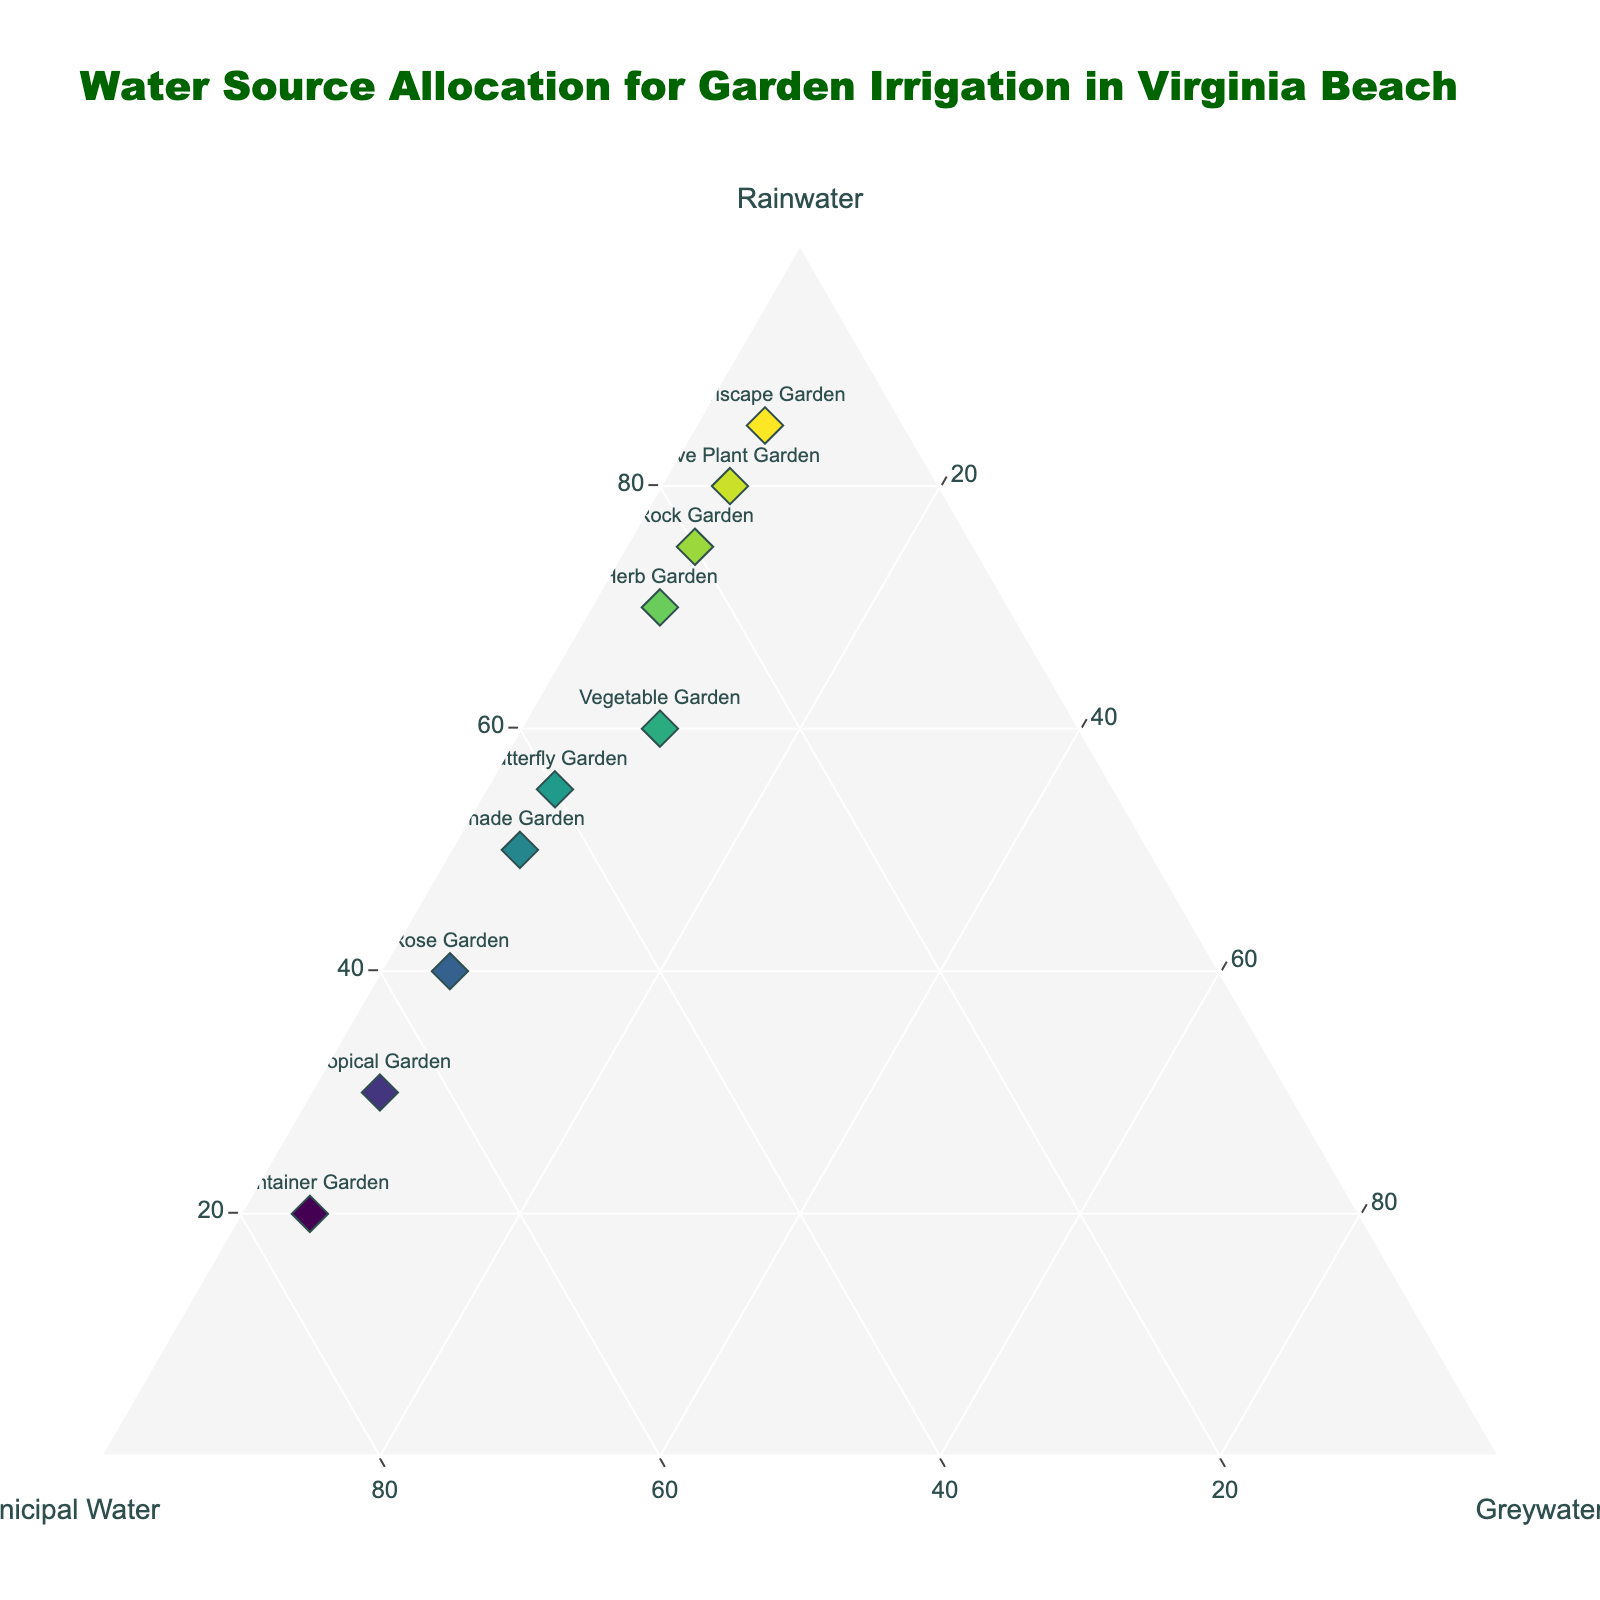What is the title of the ternary plot? The title of the plot is a main visual element and is prominently placed at the top of the figure.
Answer: Water Source Allocation for Garden Irrigation in Virginia Beach Which garden type uses the highest percentage of rainwater? Look for the garden type positioned closest to the Rainwater axis. The label corresponding to the highest value on the Rainwater axis will indicate the garden type.
Answer: Xeriscape Garden How many garden types use more than 50% of municipal water? Identify the points located more than halfway towards the Municipal Water vertex. Count these data points.
Answer: 3 What is the total percentage of all water sources for the Herb Garden? Each data point represents proportions of rainwater, municipal water, and greywater that sum to 100%. Verify it visually. For the Herb Garden: 70% Rainwater + 25% Municipal Water + 5% Greywater = 100%.
Answer: 100% Which gardens use exactly 5% greywater? Locate the gardens along the line representing 5% Greywater. Check the corresponding labels.
Answer: Rose Garden, Herb Garden, Native Plant Garden, Butterfly Garden, Container Garden, Tropical Garden, Rock Garden, Shade Garden, Xeriscape Garden Which garden has the highest combined use of rainwater and greywater? For each garden, add the percentages of rainwater and greywater, and find the garden with the highest sum.
Answer: Xeriscape Garden What is the difference in rainwater usage between the Vegetable Garden and the Container Garden? Subtract the rainwater percentage of the Container Garden from the Vegetable Garden's rainwater percentage: 60% - 20%.
Answer: 40% Do any gardens have an equal percentage of rainwater and municipal water usage? Check the plot for any point that lies on the line equidistant between Rainwater and Municipal Water vertices and verify their percentages.
Answer: No Which garden type is the most reliant on municipal water? Find the data point closest to the Municipal Water vertex. Identify this garden type.
Answer: Container Garden Compare the rainwater usage of the Butterfly Garden and Tropical Garden. Which uses more rainwater and by how much? Look at the rainwater percentages for both gardens: Butterfly Garden (55%) and Tropical Garden (30%). Subtract the smaller from the larger: 55% - 30%.
Answer: Butterfly Garden by 25% 